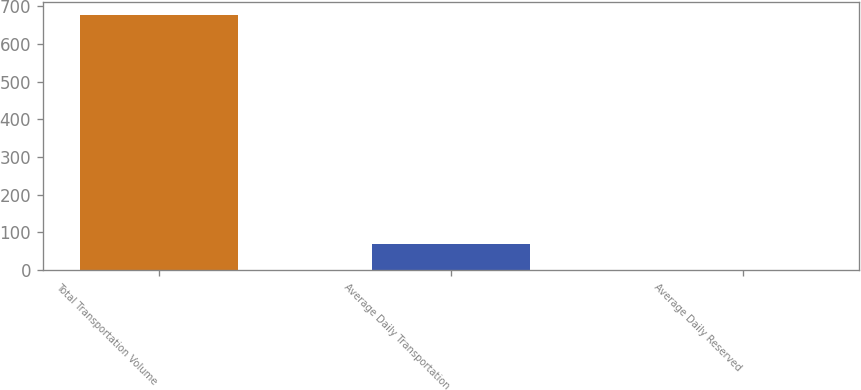<chart> <loc_0><loc_0><loc_500><loc_500><bar_chart><fcel>Total Transportation Volume<fcel>Average Daily Transportation<fcel>Average Daily Reserved<nl><fcel>676<fcel>68.41<fcel>0.9<nl></chart> 